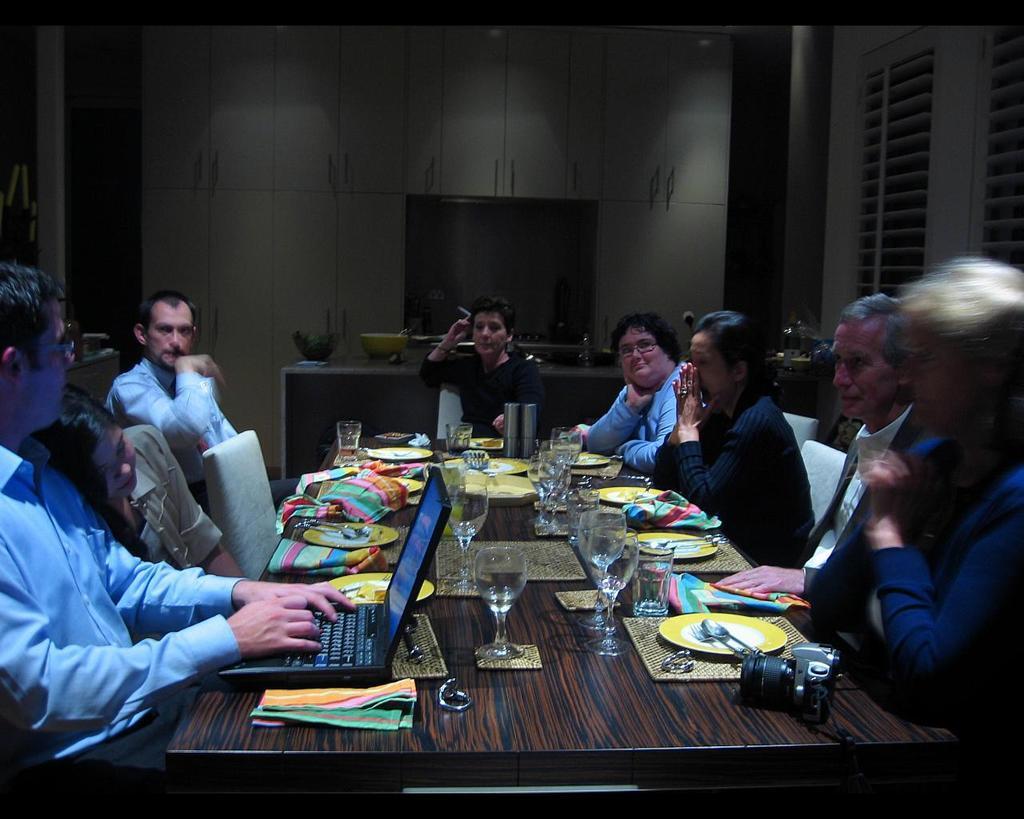Describe this image in one or two sentences. The picture is taken in a closed room where people are sitting on the chairs in front of the table and on the table there are glasses, napkins, plates ,spoons and a laptop and a camera are present and at the centre there is one big tv on the table placed and behind that there are racks present. 